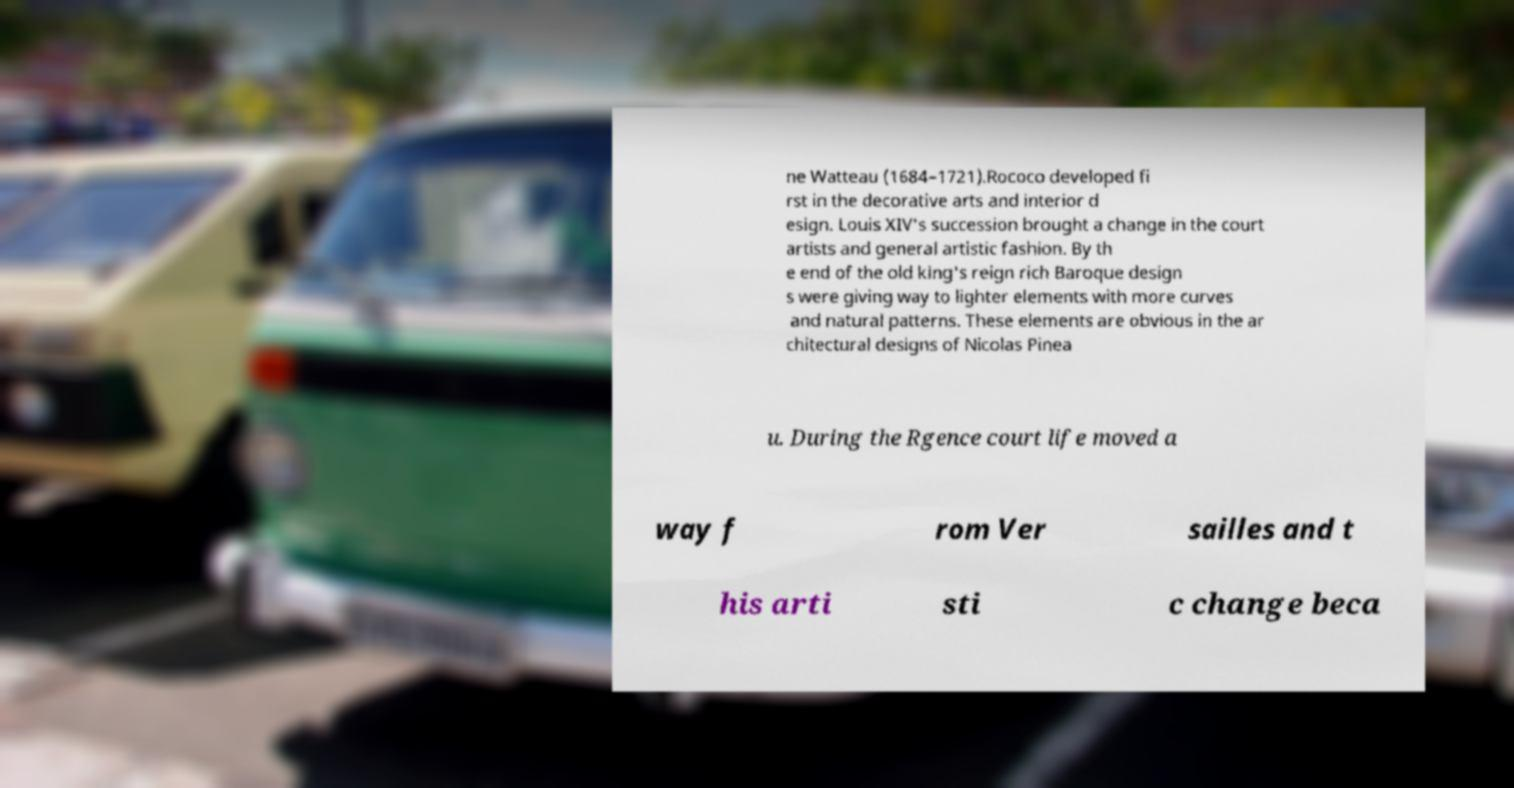I need the written content from this picture converted into text. Can you do that? ne Watteau (1684–1721).Rococo developed fi rst in the decorative arts and interior d esign. Louis XIV's succession brought a change in the court artists and general artistic fashion. By th e end of the old king's reign rich Baroque design s were giving way to lighter elements with more curves and natural patterns. These elements are obvious in the ar chitectural designs of Nicolas Pinea u. During the Rgence court life moved a way f rom Ver sailles and t his arti sti c change beca 